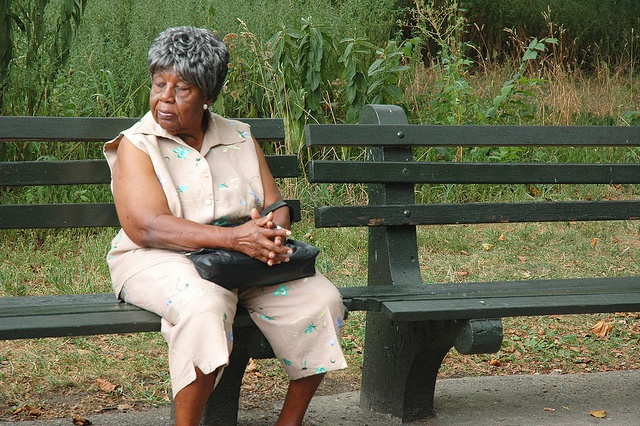Describe the objects in this image and their specific colors. I can see bench in black, gray, olive, and darkgreen tones, people in black, lightgray, tan, darkgray, and gray tones, bench in black, gray, darkgreen, and olive tones, and handbag in black, gray, purple, and darkgray tones in this image. 